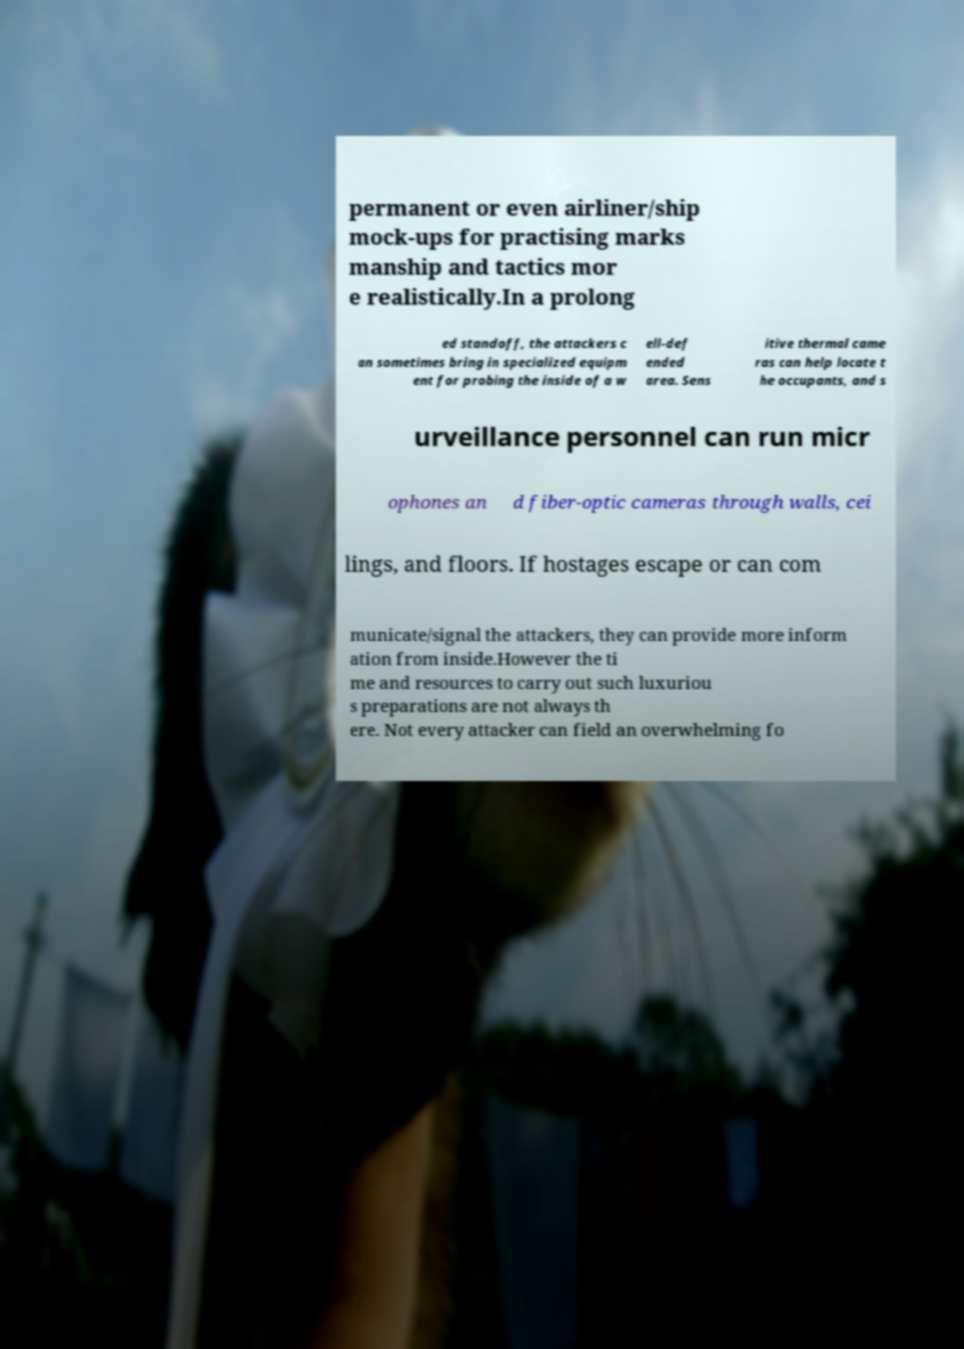Can you accurately transcribe the text from the provided image for me? permanent or even airliner/ship mock-ups for practising marks manship and tactics mor e realistically.In a prolong ed standoff, the attackers c an sometimes bring in specialized equipm ent for probing the inside of a w ell-def ended area. Sens itive thermal came ras can help locate t he occupants, and s urveillance personnel can run micr ophones an d fiber-optic cameras through walls, cei lings, and floors. If hostages escape or can com municate/signal the attackers, they can provide more inform ation from inside.However the ti me and resources to carry out such luxuriou s preparations are not always th ere. Not every attacker can field an overwhelming fo 